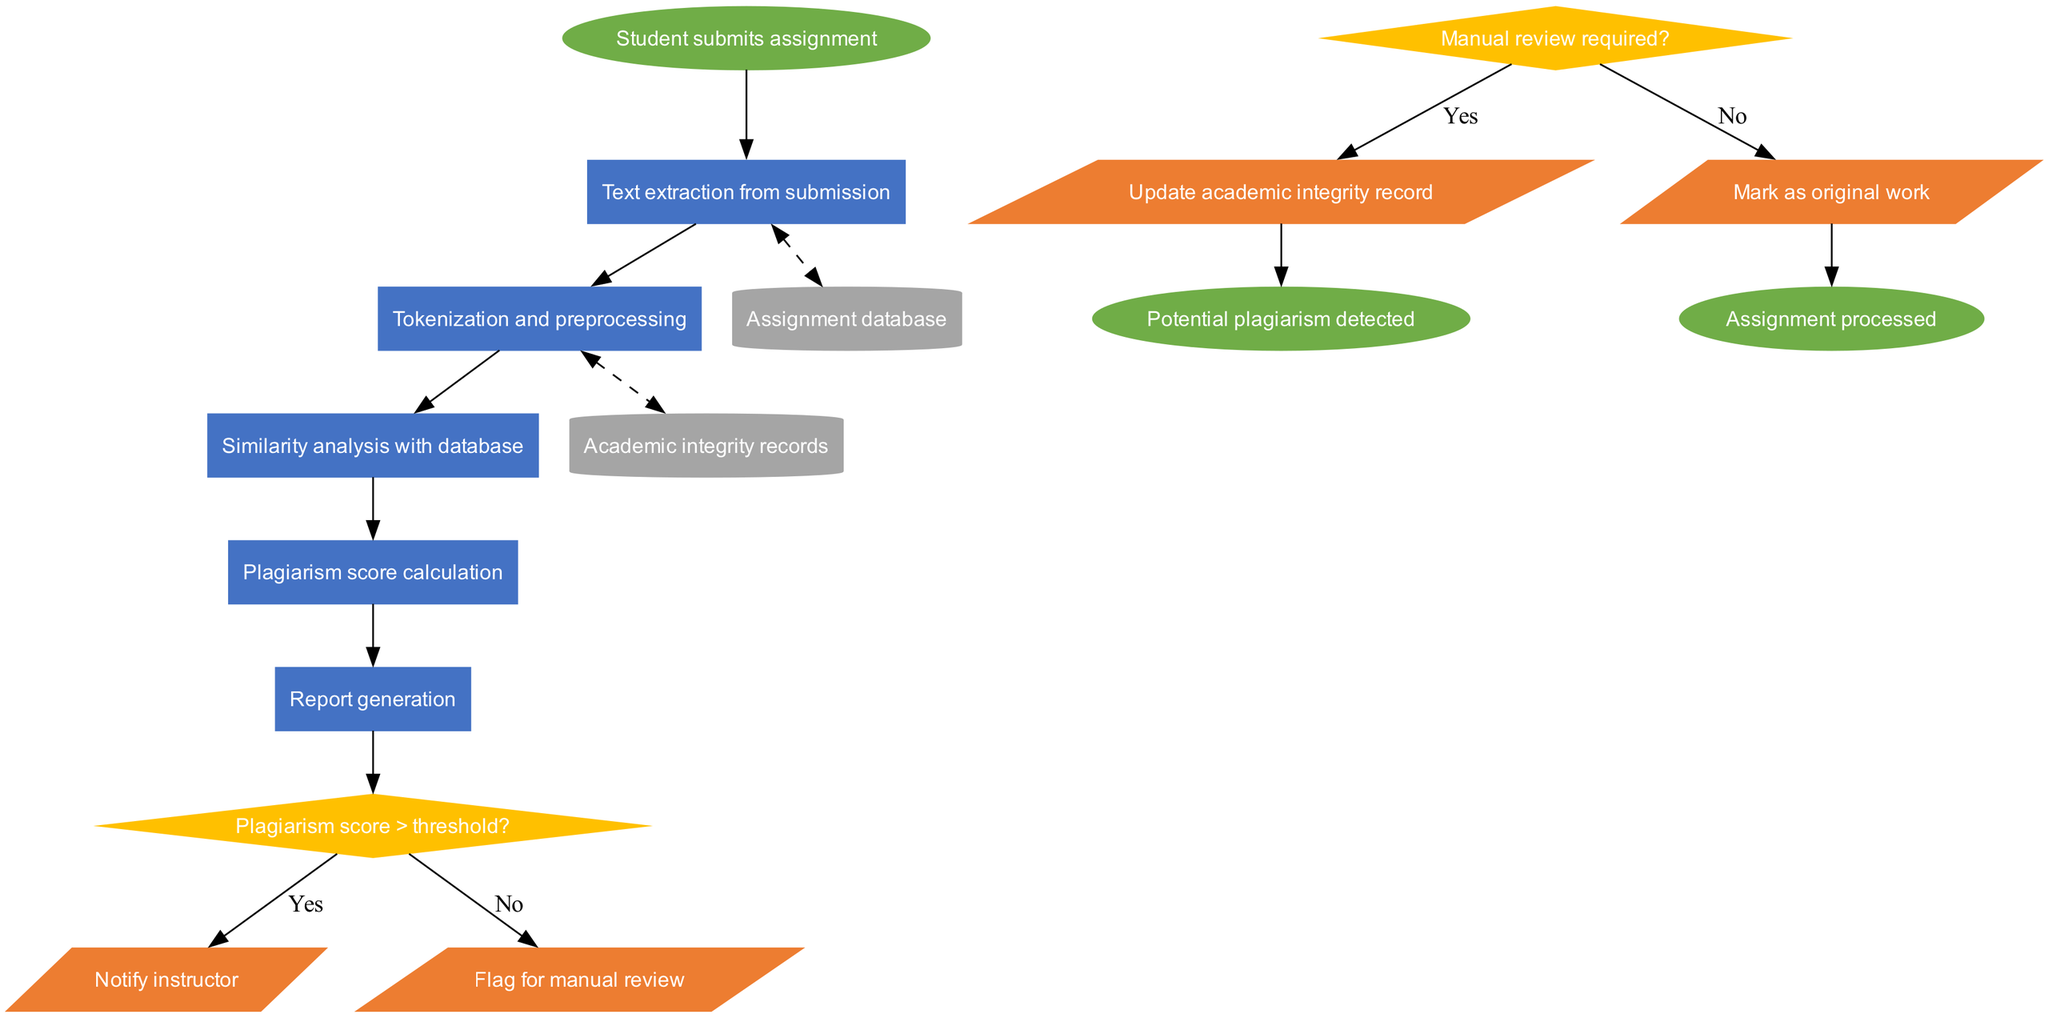What is the start node of the diagram? The start node is defined as the first action in the process. Based on the information provided, the start node is "Student submits assignment."
Answer: Student submits assignment How many processes are there in the diagram? The number of processes can be determined by counting the items listed under the "processes" section. There are five processes listed.
Answer: 5 What type of node is "Plagiarism score > threshold?" The question requires identifying the shape of the node associated with the decision. Based on the data given, this node is a decision node, represented as a diamond shape.
Answer: Diamond Which node does "Notify instructor" connect to? To identify the connection, we can look at the outputs and determine which decision leads to notifying the instructor. The path shows that this output is linked to the first decision node regarding the plagiarism score exceeding the threshold.
Answer: Decision node What happens if the plagiarism score is below the threshold? This question requires tracing the flow from the decision node. If the plagiarism score is not greater than the threshold, the output “Mark as original work” is activated according to the diagram's specified connections.
Answer: Mark as original work What data store is used for academic integrity records? This involves identifying the nodes listed in the "dataStores" section and specifically looking for the description "Academic integrity records." This is directly found in the list provided.
Answer: Academic integrity records How many output nodes are present in the flowchart? This question requires counting the number of items under the "outputs." There are four outputs listed in the data provided.
Answer: 4 What is the result if manual review is required? This can be deduced from the decision regarding whether a manual review is needed; if confirmed (yes), it leads to the output "Flag for manual review." That indicates that this is the resulting action or output from that decision.
Answer: Flag for manual review Which node represents the end of the processing? This requires identifying the nodes categorized as "endNodes" in the diagram and understanding that both represent endings of the flow. The end identified can vary based on the output that leads into them.
Answer: Assignment processed 